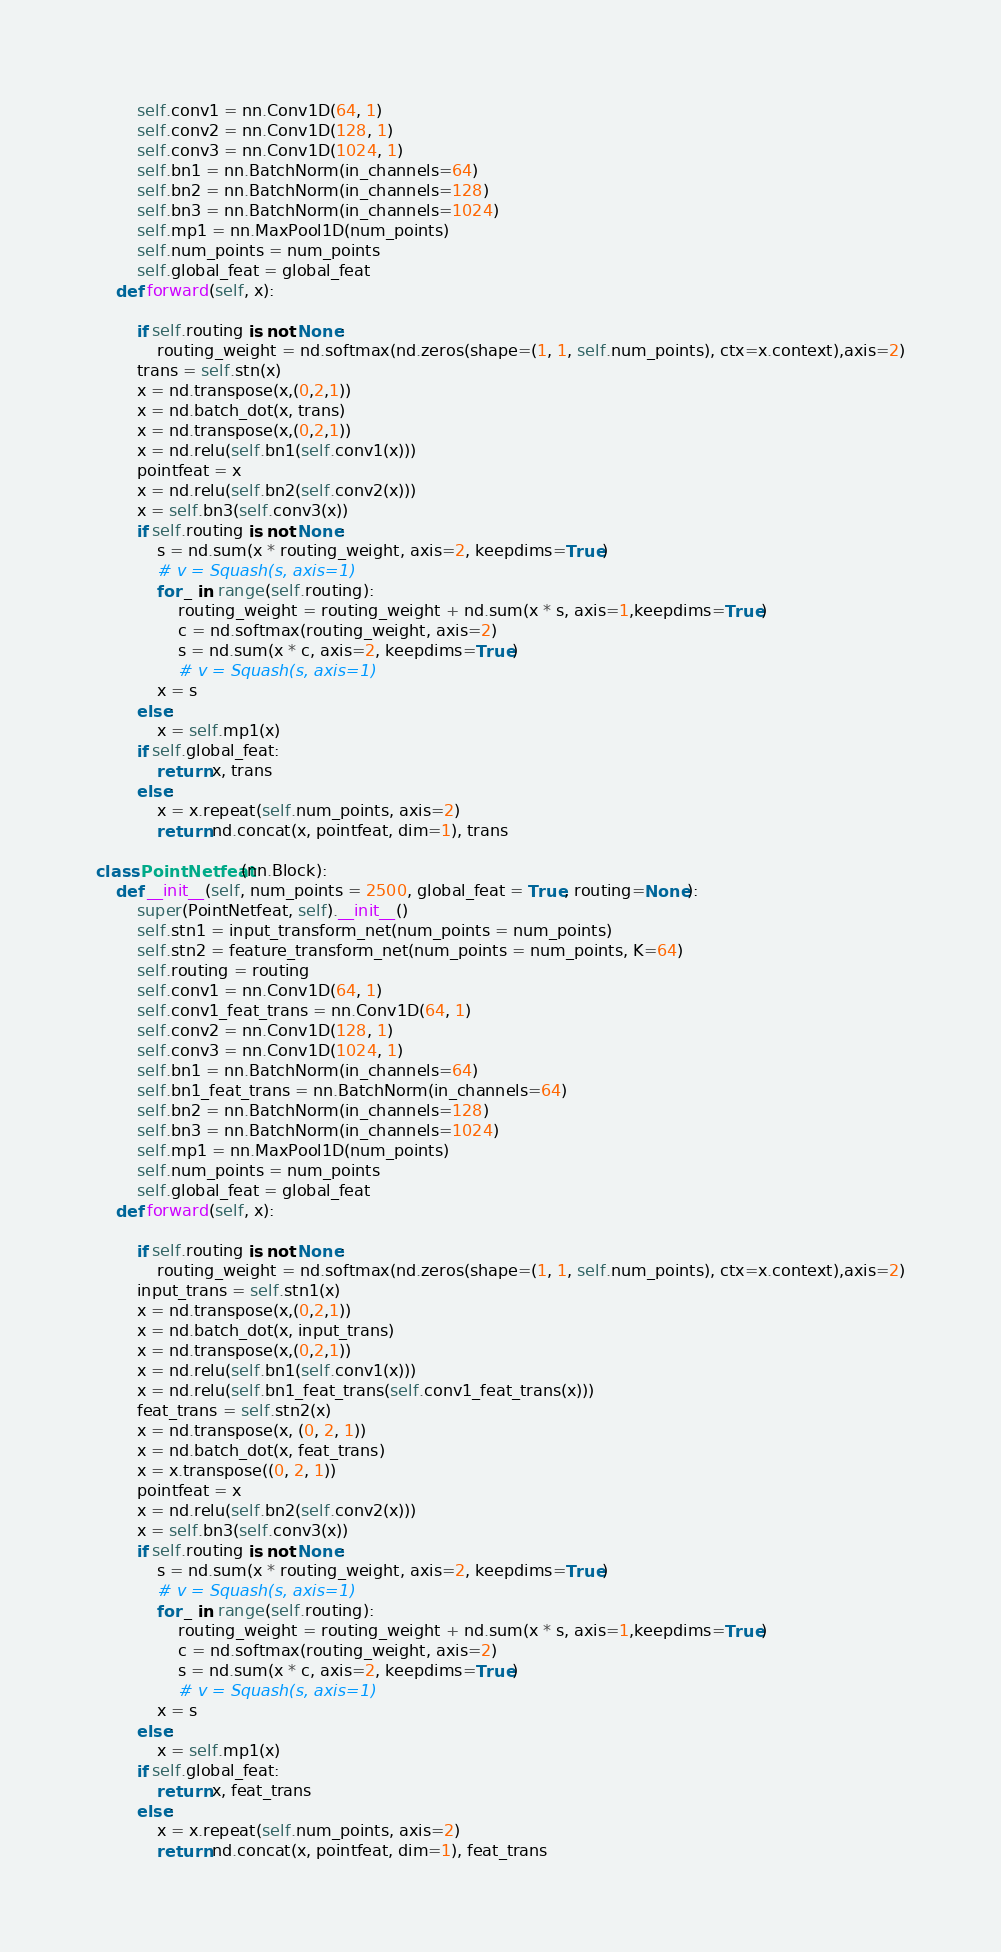Convert code to text. <code><loc_0><loc_0><loc_500><loc_500><_Python_>        self.conv1 = nn.Conv1D(64, 1)
        self.conv2 = nn.Conv1D(128, 1)
        self.conv3 = nn.Conv1D(1024, 1)
        self.bn1 = nn.BatchNorm(in_channels=64)
        self.bn2 = nn.BatchNorm(in_channels=128)
        self.bn3 = nn.BatchNorm(in_channels=1024)
        self.mp1 = nn.MaxPool1D(num_points)
        self.num_points = num_points
        self.global_feat = global_feat
    def forward(self, x):

        if self.routing is not None:
            routing_weight = nd.softmax(nd.zeros(shape=(1, 1, self.num_points), ctx=x.context),axis=2)
        trans = self.stn(x)
        x = nd.transpose(x,(0,2,1))
        x = nd.batch_dot(x, trans)
        x = nd.transpose(x,(0,2,1))
        x = nd.relu(self.bn1(self.conv1(x)))
        pointfeat = x
        x = nd.relu(self.bn2(self.conv2(x)))
        x = self.bn3(self.conv3(x))
        if self.routing is not None:
            s = nd.sum(x * routing_weight, axis=2, keepdims=True)
            # v = Squash(s, axis=1)
            for _ in range(self.routing):
                routing_weight = routing_weight + nd.sum(x * s, axis=1,keepdims=True)
                c = nd.softmax(routing_weight, axis=2)
                s = nd.sum(x * c, axis=2, keepdims=True)
                # v = Squash(s, axis=1)
            x = s
        else:
            x = self.mp1(x)
        if self.global_feat:
            return x, trans
        else:
            x = x.repeat(self.num_points, axis=2)
            return nd.concat(x, pointfeat, dim=1), trans

class PointNetfeat(nn.Block):
    def __init__(self, num_points = 2500, global_feat = True, routing=None):
        super(PointNetfeat, self).__init__()
        self.stn1 = input_transform_net(num_points = num_points)
        self.stn2 = feature_transform_net(num_points = num_points, K=64)
        self.routing = routing
        self.conv1 = nn.Conv1D(64, 1)
        self.conv1_feat_trans = nn.Conv1D(64, 1)
        self.conv2 = nn.Conv1D(128, 1)
        self.conv3 = nn.Conv1D(1024, 1)
        self.bn1 = nn.BatchNorm(in_channels=64)
        self.bn1_feat_trans = nn.BatchNorm(in_channels=64)
        self.bn2 = nn.BatchNorm(in_channels=128)
        self.bn3 = nn.BatchNorm(in_channels=1024)
        self.mp1 = nn.MaxPool1D(num_points)
        self.num_points = num_points
        self.global_feat = global_feat
    def forward(self, x):

        if self.routing is not None:
            routing_weight = nd.softmax(nd.zeros(shape=(1, 1, self.num_points), ctx=x.context),axis=2)
        input_trans = self.stn1(x)
        x = nd.transpose(x,(0,2,1))
        x = nd.batch_dot(x, input_trans)
        x = nd.transpose(x,(0,2,1))
        x = nd.relu(self.bn1(self.conv1(x)))
        x = nd.relu(self.bn1_feat_trans(self.conv1_feat_trans(x)))
        feat_trans = self.stn2(x)
        x = nd.transpose(x, (0, 2, 1))
        x = nd.batch_dot(x, feat_trans)
        x = x.transpose((0, 2, 1))
        pointfeat = x
        x = nd.relu(self.bn2(self.conv2(x)))
        x = self.bn3(self.conv3(x))
        if self.routing is not None:
            s = nd.sum(x * routing_weight, axis=2, keepdims=True)
            # v = Squash(s, axis=1)
            for _ in range(self.routing):
                routing_weight = routing_weight + nd.sum(x * s, axis=1,keepdims=True)
                c = nd.softmax(routing_weight, axis=2)
                s = nd.sum(x * c, axis=2, keepdims=True)
                # v = Squash(s, axis=1)
            x = s
        else:
            x = self.mp1(x)
        if self.global_feat:
            return x, feat_trans
        else:
            x = x.repeat(self.num_points, axis=2)
            return nd.concat(x, pointfeat, dim=1), feat_trans</code> 